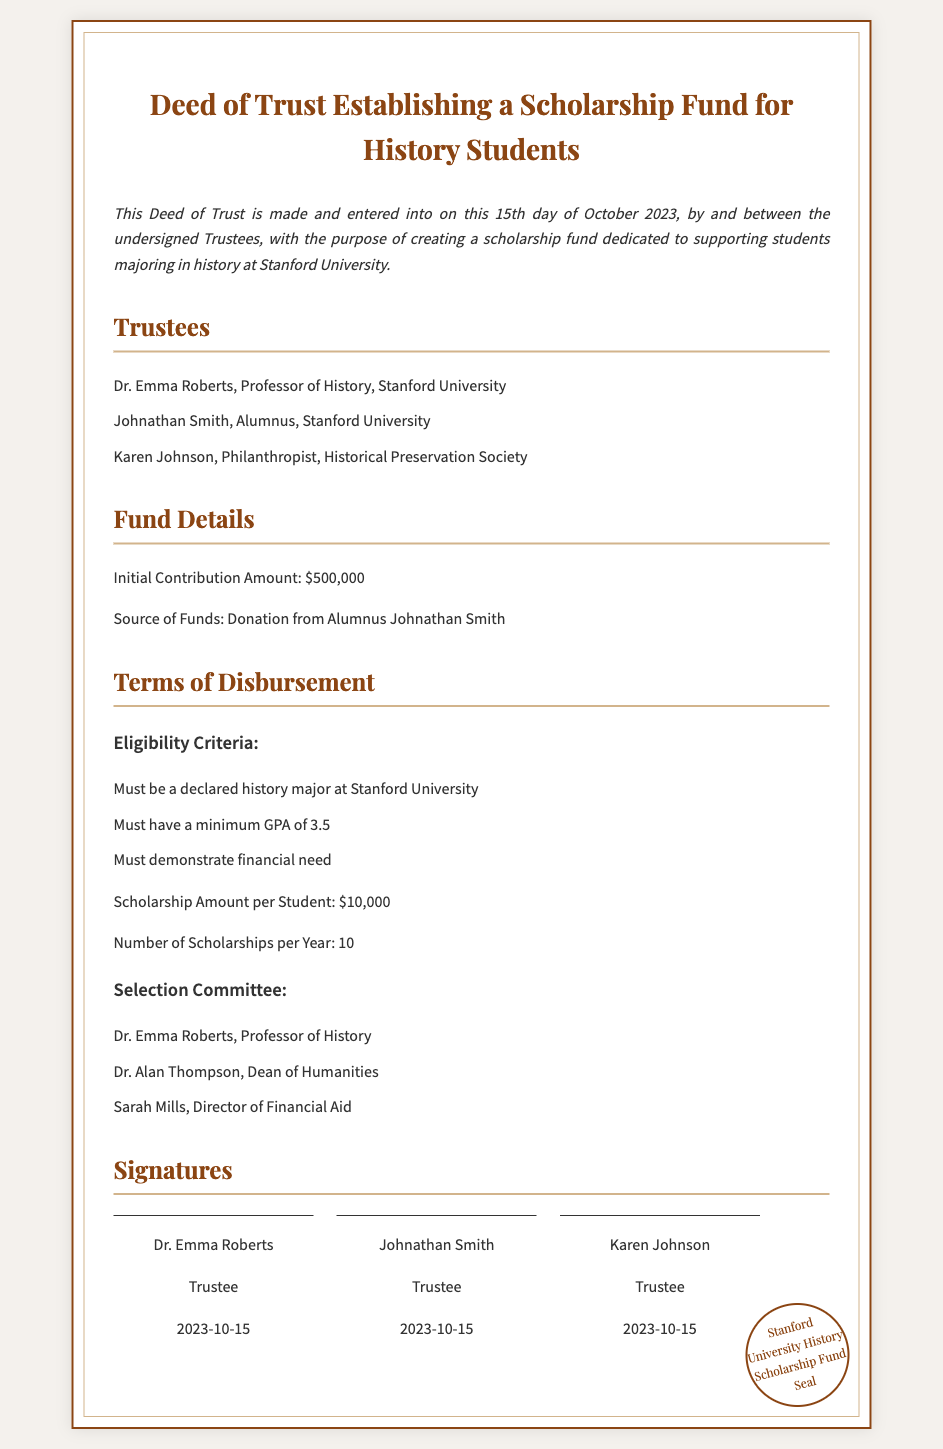What is the title of the document? The title is the main heading of the document, which is the Deed of Trust.
Answer: Deed of Trust Establishing a Scholarship Fund for History Students Who is the source of the funds? The document specifies the origin of the funds for the scholarship, indicating who contributed.
Answer: Donation from Alumnus Johnathan Smith What is the initial contribution amount? This refers to the amount of money deposited to establish the scholarship fund, as stated in the fund details.
Answer: $500,000 What are the eligibility criteria for scholarship applicants? This question focuses on listing the requirements for students to qualify for the scholarship, as outlined under the terms of disbursement.
Answer: Declared history major, minimum GPA of 3.5, demonstrate financial need How much is the scholarship amount per student? This specifies the individual financial support provided to each student who receives the scholarship.
Answer: $10,000 How many scholarships will be awarded per year? This indicates the total number of scholarships that will be granted annually, as mentioned in the terms section.
Answer: 10 Who is on the selection committee? This asks for the names of the individuals responsible for choosing scholarship recipients, as described in the terms section.
Answer: Dr. Emma Roberts, Dr. Alan Thompson, Sarah Mills What is the date the deed was signed? This directly refers to the date when the trustees finalized the deed, found in the introduction.
Answer: 2023-10-15 